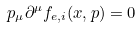Convert formula to latex. <formula><loc_0><loc_0><loc_500><loc_500>p _ { \mu } \partial ^ { \mu } f _ { { e } , i } ( x , p ) = 0</formula> 